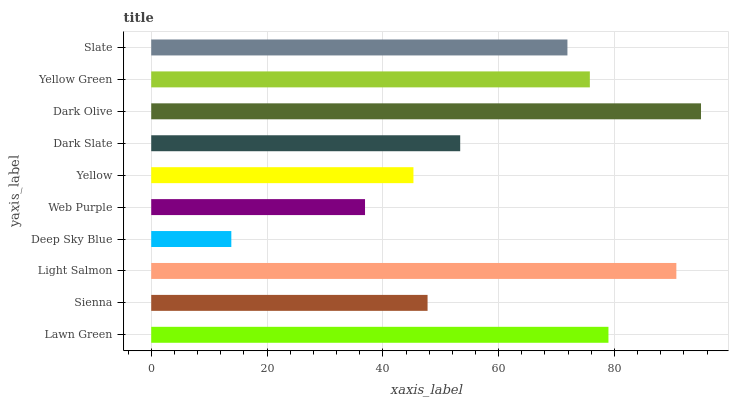Is Deep Sky Blue the minimum?
Answer yes or no. Yes. Is Dark Olive the maximum?
Answer yes or no. Yes. Is Sienna the minimum?
Answer yes or no. No. Is Sienna the maximum?
Answer yes or no. No. Is Lawn Green greater than Sienna?
Answer yes or no. Yes. Is Sienna less than Lawn Green?
Answer yes or no. Yes. Is Sienna greater than Lawn Green?
Answer yes or no. No. Is Lawn Green less than Sienna?
Answer yes or no. No. Is Slate the high median?
Answer yes or no. Yes. Is Dark Slate the low median?
Answer yes or no. Yes. Is Sienna the high median?
Answer yes or no. No. Is Slate the low median?
Answer yes or no. No. 